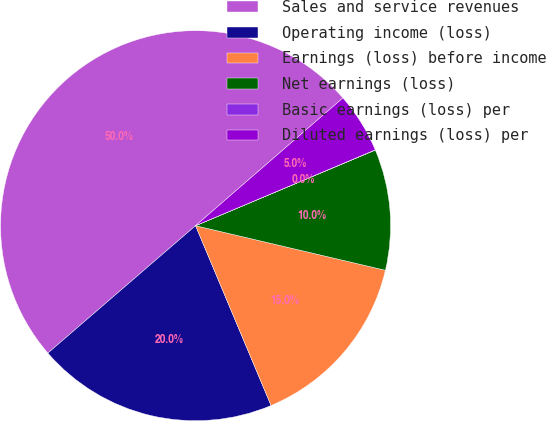Convert chart. <chart><loc_0><loc_0><loc_500><loc_500><pie_chart><fcel>Sales and service revenues<fcel>Operating income (loss)<fcel>Earnings (loss) before income<fcel>Net earnings (loss)<fcel>Basic earnings (loss) per<fcel>Diluted earnings (loss) per<nl><fcel>49.96%<fcel>20.0%<fcel>15.0%<fcel>10.01%<fcel>0.02%<fcel>5.01%<nl></chart> 